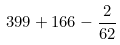<formula> <loc_0><loc_0><loc_500><loc_500>3 9 9 + 1 6 6 - \frac { 2 } { 6 2 }</formula> 